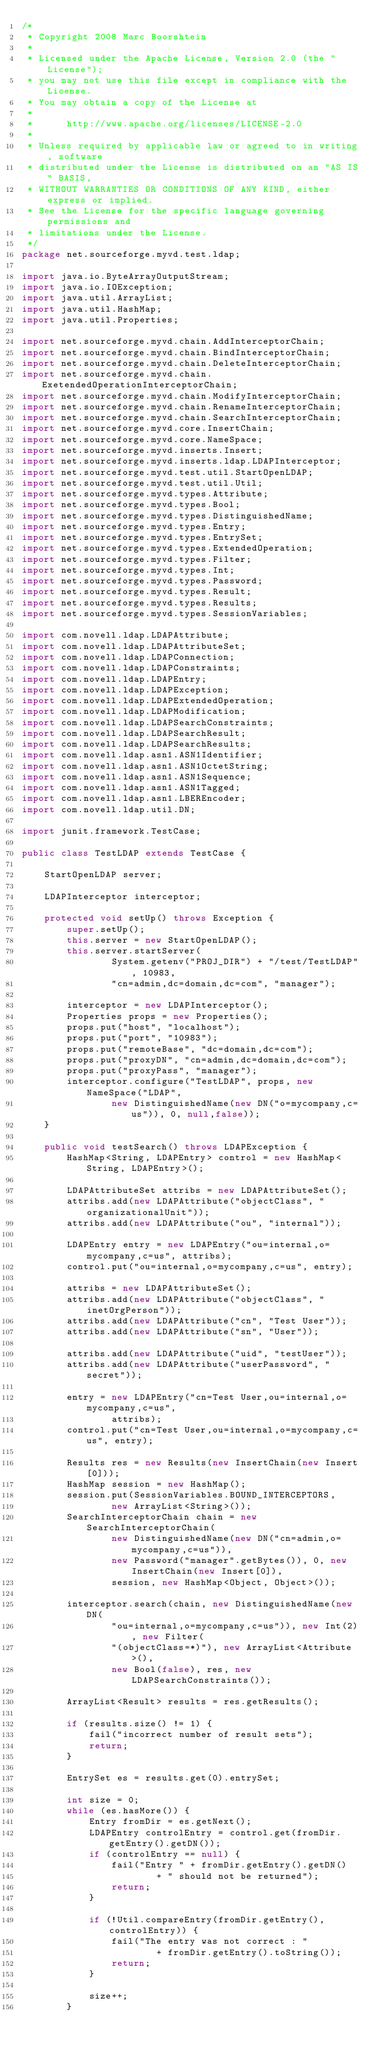<code> <loc_0><loc_0><loc_500><loc_500><_Java_>/*
 * Copyright 2008 Marc Boorshtein 
 * 
 * Licensed under the Apache License, Version 2.0 (the "License"); 
 * you may not use this file except in compliance with the License. 
 * You may obtain a copy of the License at 
 * 
 * 		http://www.apache.org/licenses/LICENSE-2.0 
 * 
 * Unless required by applicable law or agreed to in writing, software 
 * distributed under the License is distributed on an "AS IS" BASIS, 
 * WITHOUT WARRANTIES OR CONDITIONS OF ANY KIND, either express or implied. 
 * See the License for the specific language governing permissions and 
 * limitations under the License.
 */
package net.sourceforge.myvd.test.ldap;

import java.io.ByteArrayOutputStream;
import java.io.IOException;
import java.util.ArrayList;
import java.util.HashMap;
import java.util.Properties;

import net.sourceforge.myvd.chain.AddInterceptorChain;
import net.sourceforge.myvd.chain.BindInterceptorChain;
import net.sourceforge.myvd.chain.DeleteInterceptorChain;
import net.sourceforge.myvd.chain.ExetendedOperationInterceptorChain;
import net.sourceforge.myvd.chain.ModifyInterceptorChain;
import net.sourceforge.myvd.chain.RenameInterceptorChain;
import net.sourceforge.myvd.chain.SearchInterceptorChain;
import net.sourceforge.myvd.core.InsertChain;
import net.sourceforge.myvd.core.NameSpace;
import net.sourceforge.myvd.inserts.Insert;
import net.sourceforge.myvd.inserts.ldap.LDAPInterceptor;
import net.sourceforge.myvd.test.util.StartOpenLDAP;
import net.sourceforge.myvd.test.util.Util;
import net.sourceforge.myvd.types.Attribute;
import net.sourceforge.myvd.types.Bool;
import net.sourceforge.myvd.types.DistinguishedName;
import net.sourceforge.myvd.types.Entry;
import net.sourceforge.myvd.types.EntrySet;
import net.sourceforge.myvd.types.ExtendedOperation;
import net.sourceforge.myvd.types.Filter;
import net.sourceforge.myvd.types.Int;
import net.sourceforge.myvd.types.Password;
import net.sourceforge.myvd.types.Result;
import net.sourceforge.myvd.types.Results;
import net.sourceforge.myvd.types.SessionVariables;

import com.novell.ldap.LDAPAttribute;
import com.novell.ldap.LDAPAttributeSet;
import com.novell.ldap.LDAPConnection;
import com.novell.ldap.LDAPConstraints;
import com.novell.ldap.LDAPEntry;
import com.novell.ldap.LDAPException;
import com.novell.ldap.LDAPExtendedOperation;
import com.novell.ldap.LDAPModification;
import com.novell.ldap.LDAPSearchConstraints;
import com.novell.ldap.LDAPSearchResult;
import com.novell.ldap.LDAPSearchResults;
import com.novell.ldap.asn1.ASN1Identifier;
import com.novell.ldap.asn1.ASN1OctetString;
import com.novell.ldap.asn1.ASN1Sequence;
import com.novell.ldap.asn1.ASN1Tagged;
import com.novell.ldap.asn1.LBEREncoder;
import com.novell.ldap.util.DN;

import junit.framework.TestCase;

public class TestLDAP extends TestCase {

	StartOpenLDAP server;

	LDAPInterceptor interceptor;

	protected void setUp() throws Exception {
		super.setUp();
		this.server = new StartOpenLDAP();
		this.server.startServer(
				System.getenv("PROJ_DIR") + "/test/TestLDAP", 10983,
				"cn=admin,dc=domain,dc=com", "manager");

		interceptor = new LDAPInterceptor();
		Properties props = new Properties();
		props.put("host", "localhost");
		props.put("port", "10983");
		props.put("remoteBase", "dc=domain,dc=com");
		props.put("proxyDN", "cn=admin,dc=domain,dc=com");
		props.put("proxyPass", "manager");
		interceptor.configure("TestLDAP", props, new NameSpace("LDAP",
				new DistinguishedName(new DN("o=mycompany,c=us")), 0, null,false));
	}

	public void testSearch() throws LDAPException {
		HashMap<String, LDAPEntry> control = new HashMap<String, LDAPEntry>();

		LDAPAttributeSet attribs = new LDAPAttributeSet();
		attribs.add(new LDAPAttribute("objectClass", "organizationalUnit"));
		attribs.add(new LDAPAttribute("ou", "internal"));

		LDAPEntry entry = new LDAPEntry("ou=internal,o=mycompany,c=us", attribs);
		control.put("ou=internal,o=mycompany,c=us", entry);

		attribs = new LDAPAttributeSet();
		attribs.add(new LDAPAttribute("objectClass", "inetOrgPerson"));
		attribs.add(new LDAPAttribute("cn", "Test User"));
		attribs.add(new LDAPAttribute("sn", "User"));

		attribs.add(new LDAPAttribute("uid", "testUser"));
		attribs.add(new LDAPAttribute("userPassword", "secret"));

		entry = new LDAPEntry("cn=Test User,ou=internal,o=mycompany,c=us",
				attribs);
		control.put("cn=Test User,ou=internal,o=mycompany,c=us", entry);

		Results res = new Results(new InsertChain(new Insert[0]));
		HashMap session = new HashMap();
		session.put(SessionVariables.BOUND_INTERCEPTORS,
				new ArrayList<String>());
		SearchInterceptorChain chain = new SearchInterceptorChain(
				new DistinguishedName(new DN("cn=admin,o=mycompany,c=us")),
				new Password("manager".getBytes()), 0, new InsertChain(new Insert[0]),
				session, new HashMap<Object, Object>());

		interceptor.search(chain, new DistinguishedName(new DN(
				"ou=internal,o=mycompany,c=us")), new Int(2), new Filter(
				"(objectClass=*)"), new ArrayList<Attribute>(),
				new Bool(false), res, new LDAPSearchConstraints());

		ArrayList<Result> results = res.getResults();

		if (results.size() != 1) {
			fail("incorrect number of result sets");
			return;
		}

		EntrySet es = results.get(0).entrySet;

		int size = 0;
		while (es.hasMore()) {
			Entry fromDir = es.getNext();
			LDAPEntry controlEntry = control.get(fromDir.getEntry().getDN());
			if (controlEntry == null) {
				fail("Entry " + fromDir.getEntry().getDN()
						+ " should not be returned");
				return;
			}

			if (!Util.compareEntry(fromDir.getEntry(), controlEntry)) {
				fail("The entry was not correct : "
						+ fromDir.getEntry().toString());
				return;
			}

			size++;
		}
</code> 